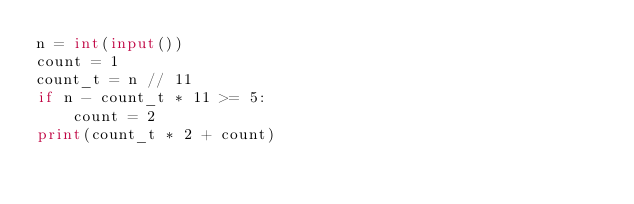Convert code to text. <code><loc_0><loc_0><loc_500><loc_500><_Python_>n = int(input())
count = 1
count_t = n // 11
if n - count_t * 11 >= 5:
    count = 2
print(count_t * 2 + count)</code> 